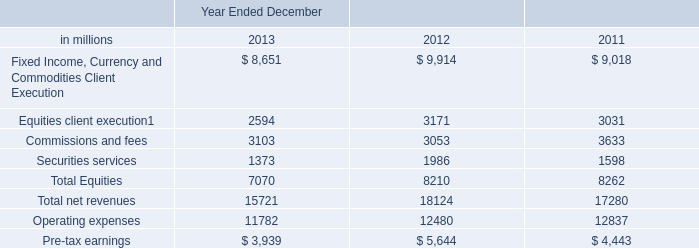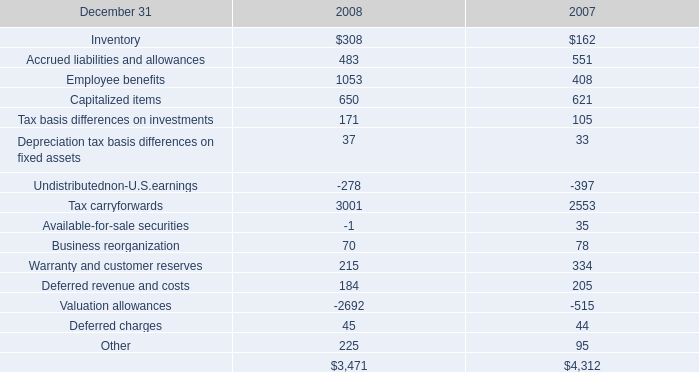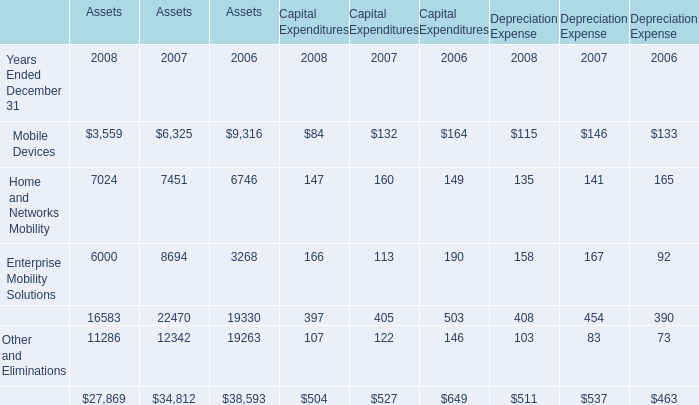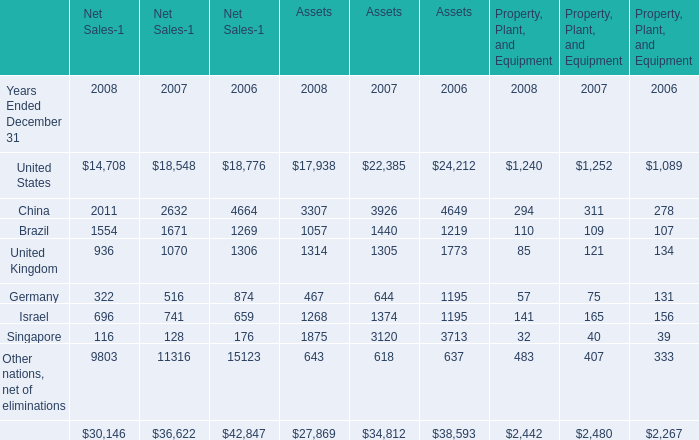In the year with the greatest proportion of Home and Networks Mobility, what is the proportion of Home and Networks Mobility to the tatal? 
Computations: (((((((((7024 + 7451) + 6746) + 147) + 160) + 149) + 135) + 141) + 165) / ((((((((27869 + 34812) + 38593) + 504) + 527) + 649) + 511) + 537) + 463))
Answer: 0.21173. 